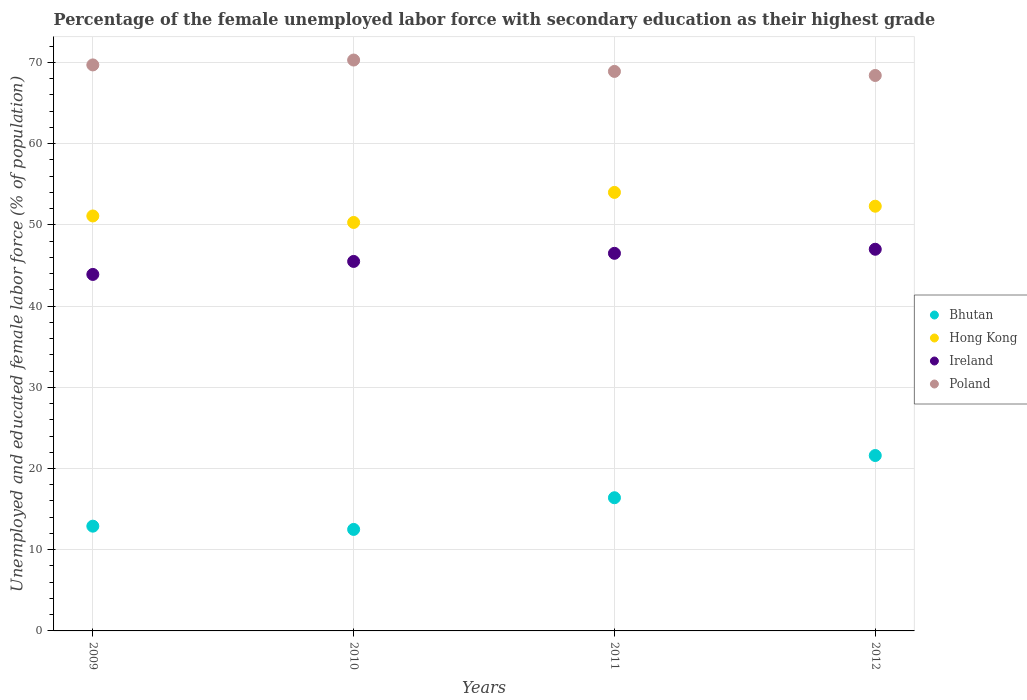Is the number of dotlines equal to the number of legend labels?
Offer a terse response. Yes. Across all years, what is the maximum percentage of the unemployed female labor force with secondary education in Bhutan?
Your response must be concise. 21.6. Across all years, what is the minimum percentage of the unemployed female labor force with secondary education in Hong Kong?
Offer a terse response. 50.3. What is the total percentage of the unemployed female labor force with secondary education in Bhutan in the graph?
Your answer should be compact. 63.4. What is the difference between the percentage of the unemployed female labor force with secondary education in Bhutan in 2011 and that in 2012?
Make the answer very short. -5.2. What is the difference between the percentage of the unemployed female labor force with secondary education in Bhutan in 2012 and the percentage of the unemployed female labor force with secondary education in Poland in 2010?
Offer a terse response. -48.7. What is the average percentage of the unemployed female labor force with secondary education in Hong Kong per year?
Your answer should be compact. 51.92. In the year 2009, what is the difference between the percentage of the unemployed female labor force with secondary education in Ireland and percentage of the unemployed female labor force with secondary education in Hong Kong?
Your answer should be very brief. -7.2. What is the ratio of the percentage of the unemployed female labor force with secondary education in Bhutan in 2009 to that in 2012?
Offer a very short reply. 0.6. Is the difference between the percentage of the unemployed female labor force with secondary education in Ireland in 2009 and 2011 greater than the difference between the percentage of the unemployed female labor force with secondary education in Hong Kong in 2009 and 2011?
Your answer should be very brief. Yes. What is the difference between the highest and the second highest percentage of the unemployed female labor force with secondary education in Hong Kong?
Make the answer very short. 1.7. What is the difference between the highest and the lowest percentage of the unemployed female labor force with secondary education in Poland?
Offer a terse response. 1.9. Is the sum of the percentage of the unemployed female labor force with secondary education in Hong Kong in 2011 and 2012 greater than the maximum percentage of the unemployed female labor force with secondary education in Bhutan across all years?
Give a very brief answer. Yes. Is it the case that in every year, the sum of the percentage of the unemployed female labor force with secondary education in Poland and percentage of the unemployed female labor force with secondary education in Ireland  is greater than the sum of percentage of the unemployed female labor force with secondary education in Hong Kong and percentage of the unemployed female labor force with secondary education in Bhutan?
Give a very brief answer. Yes. Is the percentage of the unemployed female labor force with secondary education in Hong Kong strictly greater than the percentage of the unemployed female labor force with secondary education in Bhutan over the years?
Offer a terse response. Yes. How many dotlines are there?
Your answer should be compact. 4. Are the values on the major ticks of Y-axis written in scientific E-notation?
Make the answer very short. No. Does the graph contain grids?
Your answer should be compact. Yes. Where does the legend appear in the graph?
Keep it short and to the point. Center right. What is the title of the graph?
Ensure brevity in your answer.  Percentage of the female unemployed labor force with secondary education as their highest grade. Does "Angola" appear as one of the legend labels in the graph?
Your response must be concise. No. What is the label or title of the X-axis?
Your response must be concise. Years. What is the label or title of the Y-axis?
Your response must be concise. Unemployed and educated female labor force (% of population). What is the Unemployed and educated female labor force (% of population) of Bhutan in 2009?
Make the answer very short. 12.9. What is the Unemployed and educated female labor force (% of population) of Hong Kong in 2009?
Provide a succinct answer. 51.1. What is the Unemployed and educated female labor force (% of population) of Ireland in 2009?
Provide a succinct answer. 43.9. What is the Unemployed and educated female labor force (% of population) in Poland in 2009?
Make the answer very short. 69.7. What is the Unemployed and educated female labor force (% of population) in Hong Kong in 2010?
Provide a short and direct response. 50.3. What is the Unemployed and educated female labor force (% of population) of Ireland in 2010?
Keep it short and to the point. 45.5. What is the Unemployed and educated female labor force (% of population) of Poland in 2010?
Keep it short and to the point. 70.3. What is the Unemployed and educated female labor force (% of population) in Bhutan in 2011?
Make the answer very short. 16.4. What is the Unemployed and educated female labor force (% of population) of Hong Kong in 2011?
Provide a succinct answer. 54. What is the Unemployed and educated female labor force (% of population) in Ireland in 2011?
Ensure brevity in your answer.  46.5. What is the Unemployed and educated female labor force (% of population) in Poland in 2011?
Offer a terse response. 68.9. What is the Unemployed and educated female labor force (% of population) in Bhutan in 2012?
Keep it short and to the point. 21.6. What is the Unemployed and educated female labor force (% of population) in Hong Kong in 2012?
Provide a short and direct response. 52.3. What is the Unemployed and educated female labor force (% of population) in Poland in 2012?
Your response must be concise. 68.4. Across all years, what is the maximum Unemployed and educated female labor force (% of population) of Bhutan?
Offer a terse response. 21.6. Across all years, what is the maximum Unemployed and educated female labor force (% of population) in Hong Kong?
Make the answer very short. 54. Across all years, what is the maximum Unemployed and educated female labor force (% of population) of Poland?
Provide a succinct answer. 70.3. Across all years, what is the minimum Unemployed and educated female labor force (% of population) of Hong Kong?
Your response must be concise. 50.3. Across all years, what is the minimum Unemployed and educated female labor force (% of population) in Ireland?
Offer a very short reply. 43.9. Across all years, what is the minimum Unemployed and educated female labor force (% of population) in Poland?
Your answer should be very brief. 68.4. What is the total Unemployed and educated female labor force (% of population) of Bhutan in the graph?
Offer a very short reply. 63.4. What is the total Unemployed and educated female labor force (% of population) of Hong Kong in the graph?
Give a very brief answer. 207.7. What is the total Unemployed and educated female labor force (% of population) of Ireland in the graph?
Ensure brevity in your answer.  182.9. What is the total Unemployed and educated female labor force (% of population) in Poland in the graph?
Ensure brevity in your answer.  277.3. What is the difference between the Unemployed and educated female labor force (% of population) in Bhutan in 2009 and that in 2010?
Your answer should be very brief. 0.4. What is the difference between the Unemployed and educated female labor force (% of population) of Ireland in 2009 and that in 2010?
Offer a terse response. -1.6. What is the difference between the Unemployed and educated female labor force (% of population) of Poland in 2009 and that in 2010?
Your response must be concise. -0.6. What is the difference between the Unemployed and educated female labor force (% of population) in Bhutan in 2009 and that in 2011?
Give a very brief answer. -3.5. What is the difference between the Unemployed and educated female labor force (% of population) in Hong Kong in 2009 and that in 2011?
Your answer should be very brief. -2.9. What is the difference between the Unemployed and educated female labor force (% of population) of Bhutan in 2009 and that in 2012?
Ensure brevity in your answer.  -8.7. What is the difference between the Unemployed and educated female labor force (% of population) in Hong Kong in 2009 and that in 2012?
Provide a succinct answer. -1.2. What is the difference between the Unemployed and educated female labor force (% of population) of Poland in 2009 and that in 2012?
Ensure brevity in your answer.  1.3. What is the difference between the Unemployed and educated female labor force (% of population) of Bhutan in 2010 and that in 2011?
Provide a short and direct response. -3.9. What is the difference between the Unemployed and educated female labor force (% of population) in Hong Kong in 2010 and that in 2011?
Offer a very short reply. -3.7. What is the difference between the Unemployed and educated female labor force (% of population) of Hong Kong in 2010 and that in 2012?
Your answer should be compact. -2. What is the difference between the Unemployed and educated female labor force (% of population) in Bhutan in 2011 and that in 2012?
Give a very brief answer. -5.2. What is the difference between the Unemployed and educated female labor force (% of population) of Hong Kong in 2011 and that in 2012?
Ensure brevity in your answer.  1.7. What is the difference between the Unemployed and educated female labor force (% of population) in Poland in 2011 and that in 2012?
Make the answer very short. 0.5. What is the difference between the Unemployed and educated female labor force (% of population) in Bhutan in 2009 and the Unemployed and educated female labor force (% of population) in Hong Kong in 2010?
Ensure brevity in your answer.  -37.4. What is the difference between the Unemployed and educated female labor force (% of population) of Bhutan in 2009 and the Unemployed and educated female labor force (% of population) of Ireland in 2010?
Provide a short and direct response. -32.6. What is the difference between the Unemployed and educated female labor force (% of population) of Bhutan in 2009 and the Unemployed and educated female labor force (% of population) of Poland in 2010?
Provide a succinct answer. -57.4. What is the difference between the Unemployed and educated female labor force (% of population) in Hong Kong in 2009 and the Unemployed and educated female labor force (% of population) in Poland in 2010?
Make the answer very short. -19.2. What is the difference between the Unemployed and educated female labor force (% of population) in Ireland in 2009 and the Unemployed and educated female labor force (% of population) in Poland in 2010?
Offer a terse response. -26.4. What is the difference between the Unemployed and educated female labor force (% of population) in Bhutan in 2009 and the Unemployed and educated female labor force (% of population) in Hong Kong in 2011?
Offer a terse response. -41.1. What is the difference between the Unemployed and educated female labor force (% of population) in Bhutan in 2009 and the Unemployed and educated female labor force (% of population) in Ireland in 2011?
Offer a terse response. -33.6. What is the difference between the Unemployed and educated female labor force (% of population) of Bhutan in 2009 and the Unemployed and educated female labor force (% of population) of Poland in 2011?
Ensure brevity in your answer.  -56. What is the difference between the Unemployed and educated female labor force (% of population) in Hong Kong in 2009 and the Unemployed and educated female labor force (% of population) in Poland in 2011?
Provide a short and direct response. -17.8. What is the difference between the Unemployed and educated female labor force (% of population) of Bhutan in 2009 and the Unemployed and educated female labor force (% of population) of Hong Kong in 2012?
Ensure brevity in your answer.  -39.4. What is the difference between the Unemployed and educated female labor force (% of population) of Bhutan in 2009 and the Unemployed and educated female labor force (% of population) of Ireland in 2012?
Your answer should be very brief. -34.1. What is the difference between the Unemployed and educated female labor force (% of population) of Bhutan in 2009 and the Unemployed and educated female labor force (% of population) of Poland in 2012?
Give a very brief answer. -55.5. What is the difference between the Unemployed and educated female labor force (% of population) of Hong Kong in 2009 and the Unemployed and educated female labor force (% of population) of Ireland in 2012?
Your answer should be very brief. 4.1. What is the difference between the Unemployed and educated female labor force (% of population) of Hong Kong in 2009 and the Unemployed and educated female labor force (% of population) of Poland in 2012?
Your answer should be compact. -17.3. What is the difference between the Unemployed and educated female labor force (% of population) of Ireland in 2009 and the Unemployed and educated female labor force (% of population) of Poland in 2012?
Ensure brevity in your answer.  -24.5. What is the difference between the Unemployed and educated female labor force (% of population) in Bhutan in 2010 and the Unemployed and educated female labor force (% of population) in Hong Kong in 2011?
Your response must be concise. -41.5. What is the difference between the Unemployed and educated female labor force (% of population) of Bhutan in 2010 and the Unemployed and educated female labor force (% of population) of Ireland in 2011?
Keep it short and to the point. -34. What is the difference between the Unemployed and educated female labor force (% of population) of Bhutan in 2010 and the Unemployed and educated female labor force (% of population) of Poland in 2011?
Give a very brief answer. -56.4. What is the difference between the Unemployed and educated female labor force (% of population) in Hong Kong in 2010 and the Unemployed and educated female labor force (% of population) in Poland in 2011?
Keep it short and to the point. -18.6. What is the difference between the Unemployed and educated female labor force (% of population) of Ireland in 2010 and the Unemployed and educated female labor force (% of population) of Poland in 2011?
Give a very brief answer. -23.4. What is the difference between the Unemployed and educated female labor force (% of population) of Bhutan in 2010 and the Unemployed and educated female labor force (% of population) of Hong Kong in 2012?
Give a very brief answer. -39.8. What is the difference between the Unemployed and educated female labor force (% of population) of Bhutan in 2010 and the Unemployed and educated female labor force (% of population) of Ireland in 2012?
Offer a terse response. -34.5. What is the difference between the Unemployed and educated female labor force (% of population) of Bhutan in 2010 and the Unemployed and educated female labor force (% of population) of Poland in 2012?
Give a very brief answer. -55.9. What is the difference between the Unemployed and educated female labor force (% of population) of Hong Kong in 2010 and the Unemployed and educated female labor force (% of population) of Ireland in 2012?
Your response must be concise. 3.3. What is the difference between the Unemployed and educated female labor force (% of population) of Hong Kong in 2010 and the Unemployed and educated female labor force (% of population) of Poland in 2012?
Make the answer very short. -18.1. What is the difference between the Unemployed and educated female labor force (% of population) of Ireland in 2010 and the Unemployed and educated female labor force (% of population) of Poland in 2012?
Provide a succinct answer. -22.9. What is the difference between the Unemployed and educated female labor force (% of population) of Bhutan in 2011 and the Unemployed and educated female labor force (% of population) of Hong Kong in 2012?
Ensure brevity in your answer.  -35.9. What is the difference between the Unemployed and educated female labor force (% of population) in Bhutan in 2011 and the Unemployed and educated female labor force (% of population) in Ireland in 2012?
Ensure brevity in your answer.  -30.6. What is the difference between the Unemployed and educated female labor force (% of population) in Bhutan in 2011 and the Unemployed and educated female labor force (% of population) in Poland in 2012?
Your response must be concise. -52. What is the difference between the Unemployed and educated female labor force (% of population) in Hong Kong in 2011 and the Unemployed and educated female labor force (% of population) in Poland in 2012?
Your response must be concise. -14.4. What is the difference between the Unemployed and educated female labor force (% of population) in Ireland in 2011 and the Unemployed and educated female labor force (% of population) in Poland in 2012?
Ensure brevity in your answer.  -21.9. What is the average Unemployed and educated female labor force (% of population) in Bhutan per year?
Provide a short and direct response. 15.85. What is the average Unemployed and educated female labor force (% of population) in Hong Kong per year?
Your answer should be very brief. 51.92. What is the average Unemployed and educated female labor force (% of population) of Ireland per year?
Provide a short and direct response. 45.73. What is the average Unemployed and educated female labor force (% of population) of Poland per year?
Provide a short and direct response. 69.33. In the year 2009, what is the difference between the Unemployed and educated female labor force (% of population) in Bhutan and Unemployed and educated female labor force (% of population) in Hong Kong?
Provide a short and direct response. -38.2. In the year 2009, what is the difference between the Unemployed and educated female labor force (% of population) in Bhutan and Unemployed and educated female labor force (% of population) in Ireland?
Ensure brevity in your answer.  -31. In the year 2009, what is the difference between the Unemployed and educated female labor force (% of population) of Bhutan and Unemployed and educated female labor force (% of population) of Poland?
Make the answer very short. -56.8. In the year 2009, what is the difference between the Unemployed and educated female labor force (% of population) of Hong Kong and Unemployed and educated female labor force (% of population) of Ireland?
Your answer should be very brief. 7.2. In the year 2009, what is the difference between the Unemployed and educated female labor force (% of population) in Hong Kong and Unemployed and educated female labor force (% of population) in Poland?
Provide a succinct answer. -18.6. In the year 2009, what is the difference between the Unemployed and educated female labor force (% of population) in Ireland and Unemployed and educated female labor force (% of population) in Poland?
Your response must be concise. -25.8. In the year 2010, what is the difference between the Unemployed and educated female labor force (% of population) of Bhutan and Unemployed and educated female labor force (% of population) of Hong Kong?
Your response must be concise. -37.8. In the year 2010, what is the difference between the Unemployed and educated female labor force (% of population) in Bhutan and Unemployed and educated female labor force (% of population) in Ireland?
Your answer should be compact. -33. In the year 2010, what is the difference between the Unemployed and educated female labor force (% of population) of Bhutan and Unemployed and educated female labor force (% of population) of Poland?
Provide a short and direct response. -57.8. In the year 2010, what is the difference between the Unemployed and educated female labor force (% of population) in Hong Kong and Unemployed and educated female labor force (% of population) in Ireland?
Provide a short and direct response. 4.8. In the year 2010, what is the difference between the Unemployed and educated female labor force (% of population) in Ireland and Unemployed and educated female labor force (% of population) in Poland?
Offer a very short reply. -24.8. In the year 2011, what is the difference between the Unemployed and educated female labor force (% of population) in Bhutan and Unemployed and educated female labor force (% of population) in Hong Kong?
Keep it short and to the point. -37.6. In the year 2011, what is the difference between the Unemployed and educated female labor force (% of population) in Bhutan and Unemployed and educated female labor force (% of population) in Ireland?
Your answer should be very brief. -30.1. In the year 2011, what is the difference between the Unemployed and educated female labor force (% of population) of Bhutan and Unemployed and educated female labor force (% of population) of Poland?
Your response must be concise. -52.5. In the year 2011, what is the difference between the Unemployed and educated female labor force (% of population) of Hong Kong and Unemployed and educated female labor force (% of population) of Ireland?
Make the answer very short. 7.5. In the year 2011, what is the difference between the Unemployed and educated female labor force (% of population) in Hong Kong and Unemployed and educated female labor force (% of population) in Poland?
Your response must be concise. -14.9. In the year 2011, what is the difference between the Unemployed and educated female labor force (% of population) in Ireland and Unemployed and educated female labor force (% of population) in Poland?
Offer a very short reply. -22.4. In the year 2012, what is the difference between the Unemployed and educated female labor force (% of population) in Bhutan and Unemployed and educated female labor force (% of population) in Hong Kong?
Your answer should be compact. -30.7. In the year 2012, what is the difference between the Unemployed and educated female labor force (% of population) of Bhutan and Unemployed and educated female labor force (% of population) of Ireland?
Give a very brief answer. -25.4. In the year 2012, what is the difference between the Unemployed and educated female labor force (% of population) of Bhutan and Unemployed and educated female labor force (% of population) of Poland?
Provide a succinct answer. -46.8. In the year 2012, what is the difference between the Unemployed and educated female labor force (% of population) in Hong Kong and Unemployed and educated female labor force (% of population) in Ireland?
Keep it short and to the point. 5.3. In the year 2012, what is the difference between the Unemployed and educated female labor force (% of population) of Hong Kong and Unemployed and educated female labor force (% of population) of Poland?
Offer a terse response. -16.1. In the year 2012, what is the difference between the Unemployed and educated female labor force (% of population) in Ireland and Unemployed and educated female labor force (% of population) in Poland?
Ensure brevity in your answer.  -21.4. What is the ratio of the Unemployed and educated female labor force (% of population) in Bhutan in 2009 to that in 2010?
Give a very brief answer. 1.03. What is the ratio of the Unemployed and educated female labor force (% of population) in Hong Kong in 2009 to that in 2010?
Make the answer very short. 1.02. What is the ratio of the Unemployed and educated female labor force (% of population) in Ireland in 2009 to that in 2010?
Ensure brevity in your answer.  0.96. What is the ratio of the Unemployed and educated female labor force (% of population) of Bhutan in 2009 to that in 2011?
Keep it short and to the point. 0.79. What is the ratio of the Unemployed and educated female labor force (% of population) of Hong Kong in 2009 to that in 2011?
Keep it short and to the point. 0.95. What is the ratio of the Unemployed and educated female labor force (% of population) of Ireland in 2009 to that in 2011?
Make the answer very short. 0.94. What is the ratio of the Unemployed and educated female labor force (% of population) in Poland in 2009 to that in 2011?
Your answer should be very brief. 1.01. What is the ratio of the Unemployed and educated female labor force (% of population) in Bhutan in 2009 to that in 2012?
Ensure brevity in your answer.  0.6. What is the ratio of the Unemployed and educated female labor force (% of population) of Hong Kong in 2009 to that in 2012?
Your answer should be very brief. 0.98. What is the ratio of the Unemployed and educated female labor force (% of population) in Ireland in 2009 to that in 2012?
Offer a very short reply. 0.93. What is the ratio of the Unemployed and educated female labor force (% of population) of Bhutan in 2010 to that in 2011?
Your response must be concise. 0.76. What is the ratio of the Unemployed and educated female labor force (% of population) of Hong Kong in 2010 to that in 2011?
Your answer should be compact. 0.93. What is the ratio of the Unemployed and educated female labor force (% of population) in Ireland in 2010 to that in 2011?
Offer a very short reply. 0.98. What is the ratio of the Unemployed and educated female labor force (% of population) in Poland in 2010 to that in 2011?
Make the answer very short. 1.02. What is the ratio of the Unemployed and educated female labor force (% of population) in Bhutan in 2010 to that in 2012?
Provide a succinct answer. 0.58. What is the ratio of the Unemployed and educated female labor force (% of population) of Hong Kong in 2010 to that in 2012?
Offer a terse response. 0.96. What is the ratio of the Unemployed and educated female labor force (% of population) in Ireland in 2010 to that in 2012?
Provide a short and direct response. 0.97. What is the ratio of the Unemployed and educated female labor force (% of population) of Poland in 2010 to that in 2012?
Provide a short and direct response. 1.03. What is the ratio of the Unemployed and educated female labor force (% of population) in Bhutan in 2011 to that in 2012?
Make the answer very short. 0.76. What is the ratio of the Unemployed and educated female labor force (% of population) of Hong Kong in 2011 to that in 2012?
Provide a succinct answer. 1.03. What is the ratio of the Unemployed and educated female labor force (% of population) in Poland in 2011 to that in 2012?
Offer a terse response. 1.01. What is the difference between the highest and the second highest Unemployed and educated female labor force (% of population) in Hong Kong?
Give a very brief answer. 1.7. 